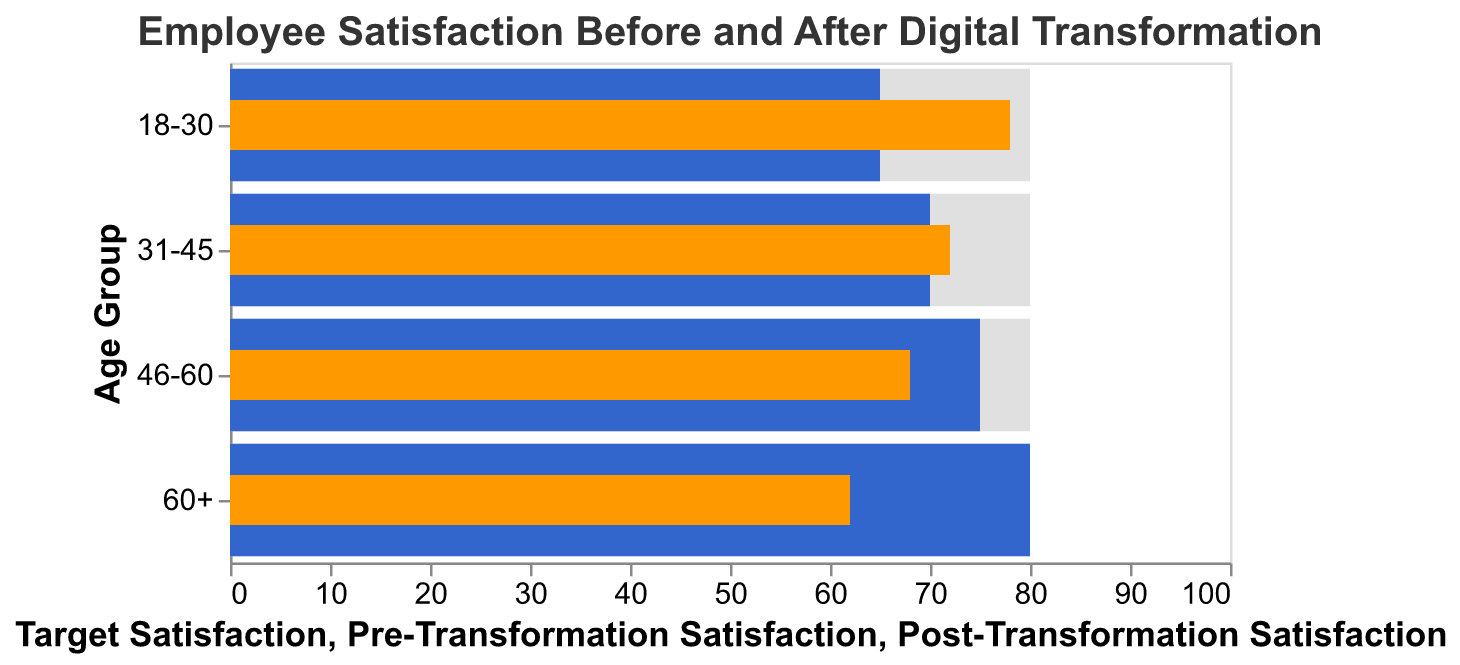What is the title of the chart? The title is usually displayed at the top of the chart, and in this case, it reads "Employee Satisfaction Before and After Digital Transformation."
Answer: Employee Satisfaction Before and After Digital Transformation Which age group has the highest pre-transformation satisfaction rate? Look at the "Pre-Transformation Satisfaction" bars and identify the highest value, which corresponds to the "60+" age group with a satisfaction rate of 80.
Answer: 60+ Which age group has the lowest post-transformation satisfaction rate? Check the "Post-Transformation Satisfaction" bars; the lowest value is 62 for the "60+" age group.
Answer: 60+ What is the difference in satisfaction for the 18-30 age group before and after digital transformation? The pre-transformation satisfaction is 65, and the post-transformation satisfaction is 78 for the 18-30 age group. Subtract 65 from 78 to get the difference.
Answer: 13 Which age group shows a decrease in satisfaction after digital transformation? Compare the pre- and post-transformation bars. The groups "46-60" and "60+" show a decrease in satisfaction (75 to 68 and 80 to 62, respectively).
Answer: 46-60, 60+ How many age groups reached or exceeded the target satisfaction rate post-transformation? The target satisfaction rate is 80 for all age groups. No age groups reached or exceeded this target post-transformation (highest is 78).
Answer: 0 What is the average pre-transformation satisfaction rate across all age groups? Add the pre-transformation satisfaction rates (65, 70, 75, 80) and divide by the number of age groups (4). The sum is 290, so the average is 290/4.
Answer: 72.5 Which age group came closest to the target satisfaction rate post-transformation? The target satisfaction rate is 80. The post-transformation rates are 78, 72, 68, and 62. The closest value to 80 is 78 for the 18-30 age group.
Answer: 18-30 What color represents the post-transformation satisfaction in the chart? The post-transformation satisfaction bars are colored in orange.
Answer: orange How many age groups experienced an increase in satisfaction after digital transformation? Check the difference between pre- and post-transformation satisfaction rates. Groups "18-30" (65 to 78) and "31-45" (70 to 72) experienced an increase.
Answer: 2 